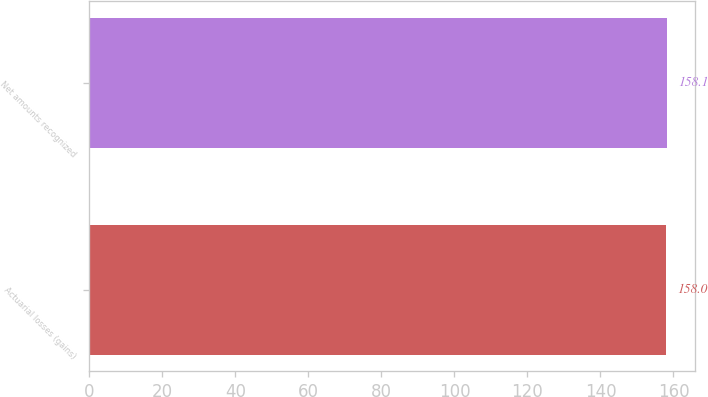<chart> <loc_0><loc_0><loc_500><loc_500><bar_chart><fcel>Actuarial losses (gains)<fcel>Net amounts recognized<nl><fcel>158<fcel>158.1<nl></chart> 